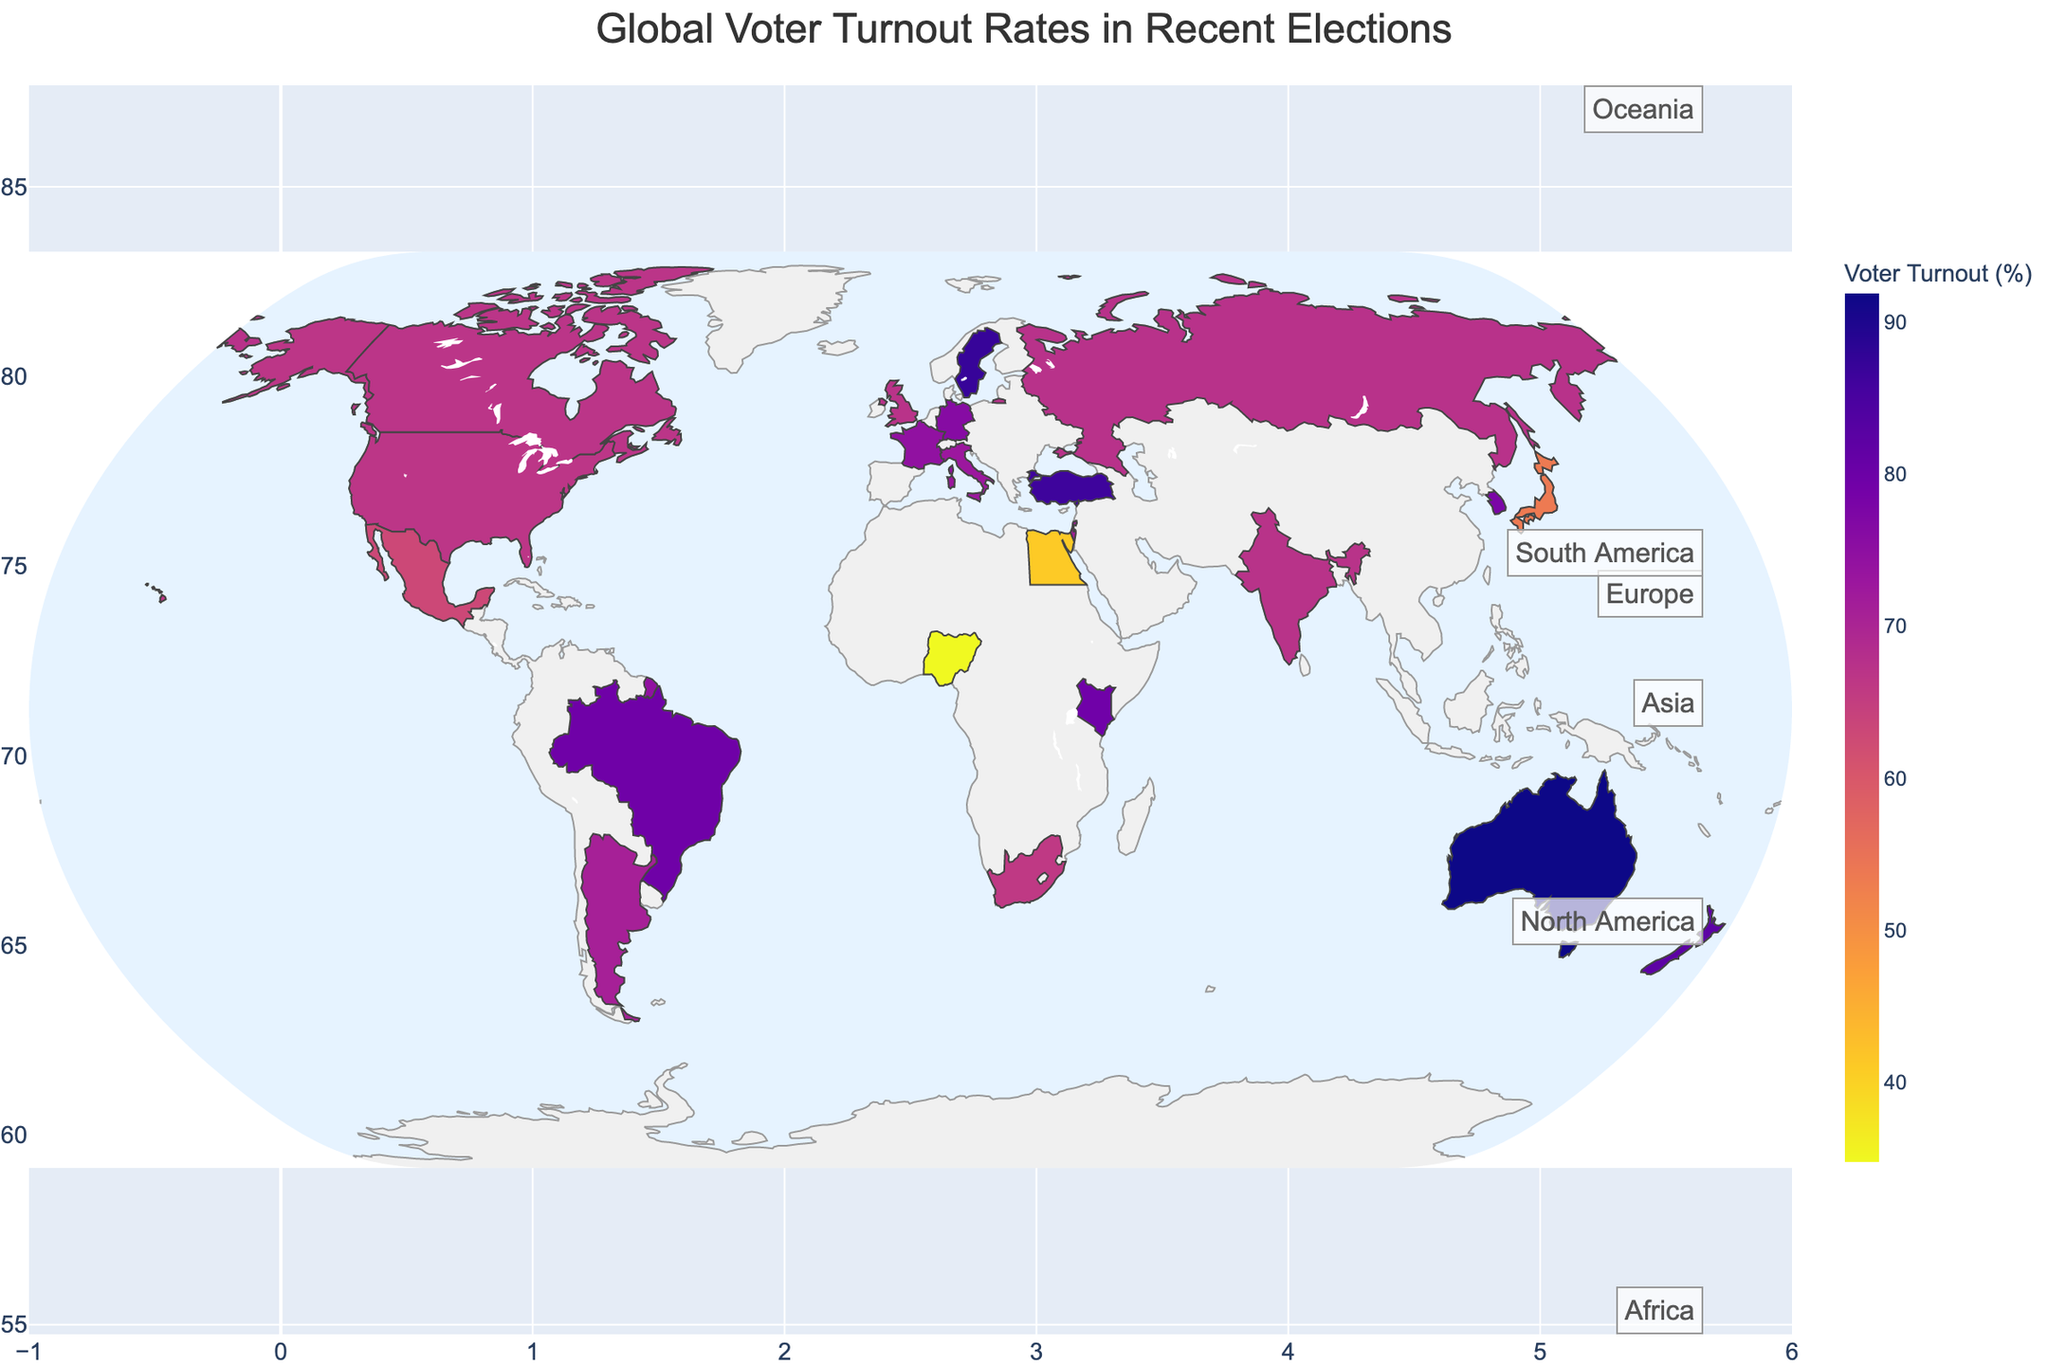How many continents are represented in the plot? To answer, identify each continent label on the figure.
Answer: 5 Which country has the highest voter turnout rate and what is it? Refer to the color intensity and hover information to locate the country with the highest voter turnout.
Answer: Australia, 91.9% What's the voter turnout rate for Japan? Use the hover information for the specific country.
Answer: 53.7% How does Africa's voter turnout rate vary among its countries? Observe the different shades for countries in Africa and note down their hover information.
Answer: South Africa (66.1%), Nigeria (34.8%), Kenya (79.5%), Egypt (41.1%) What is the average voter turnout rate in Europe? (67.3 + 74.6 + 76.2 + 72.9 + 87.2 + 67.5)/6 ≈ 74.43
Answer: 74.43% Which continent has the lowest median voter turnout rate? Identify the median voter turnout rate for each continent and compare them.
Answer: Africa Compare the voter turnout rates of North American countries. Look at the hover information for the United States, Canada, and Mexico to compare their values.
Answer: United States (66.8%), Canada (67.0%), Mexico (63.1%) What is the difference in voter turnout rate between the highest and lowest countries? Find the highest (Australia, 91.9%) and lowest (Nigeria, 34.8%) values, then subtract.
Answer: 57.1% Is there a significant variation in voter turnout rates within Asia? Observe the voter turnout rates for different countries in Asia and note the variation.
Answer: Yes, from Japan (53.7%) to Turkey (86.4%) What color scheme is used in the plot? Identify the color scale provided for the voter turnout rates.
Answer: Plasma_r 